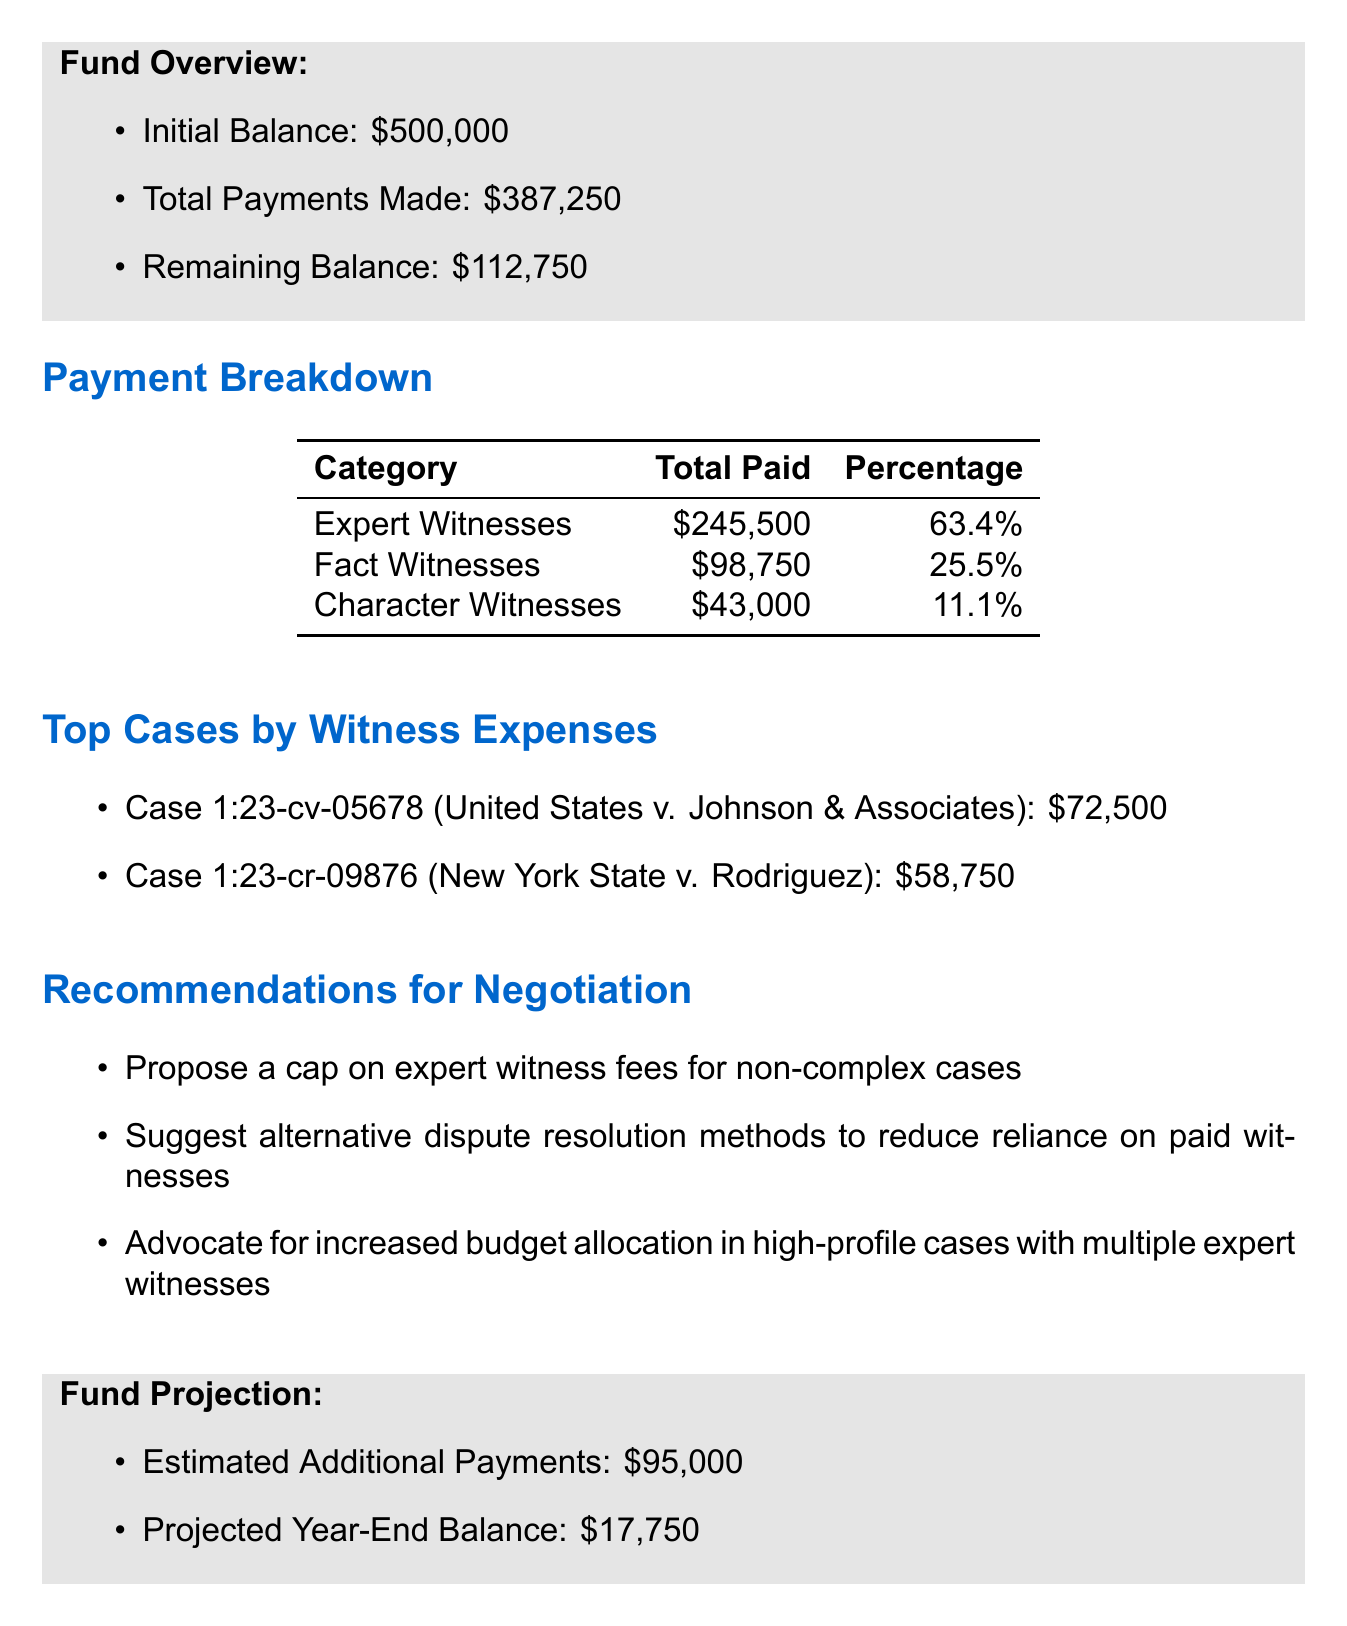What is the initial balance of the fund? The initial balance is clearly stated in the fund overview section of the document.
Answer: $500,000 How much was paid to expert witnesses? The total paid to expert witnesses is detailed in the payment breakdown table.
Answer: $245,500 What is the remaining balance of the fund? The remaining balance is specified in the fund overview section of the document.
Answer: $112,750 Which case had the highest witness expenses? By comparing the witness expenses from the top cases section, we can identify the case with the highest amount.
Answer: United States v. Johnson & Associates What percentage of total payments were made to fact witnesses? The percentage for fact witnesses is documented in the payment breakdown table, which allows us to find this information.
Answer: 25.5% What is the projected year-end balance? The projected year-end balance is found in the fund projection section, which gives an estimate for the balance at the end of the fiscal year.
Answer: $17,750 What recommendation suggests reducing reliance on paid witnesses? The recommendation specifically mentioned in the recommendations section considers modifying dispute methods.
Answer: Suggest alternative dispute resolution methods to reduce reliance on paid witnesses How much will the estimated additional payments be? The estimated additional payments are listed in the fund projection section.
Answer: $95,000 